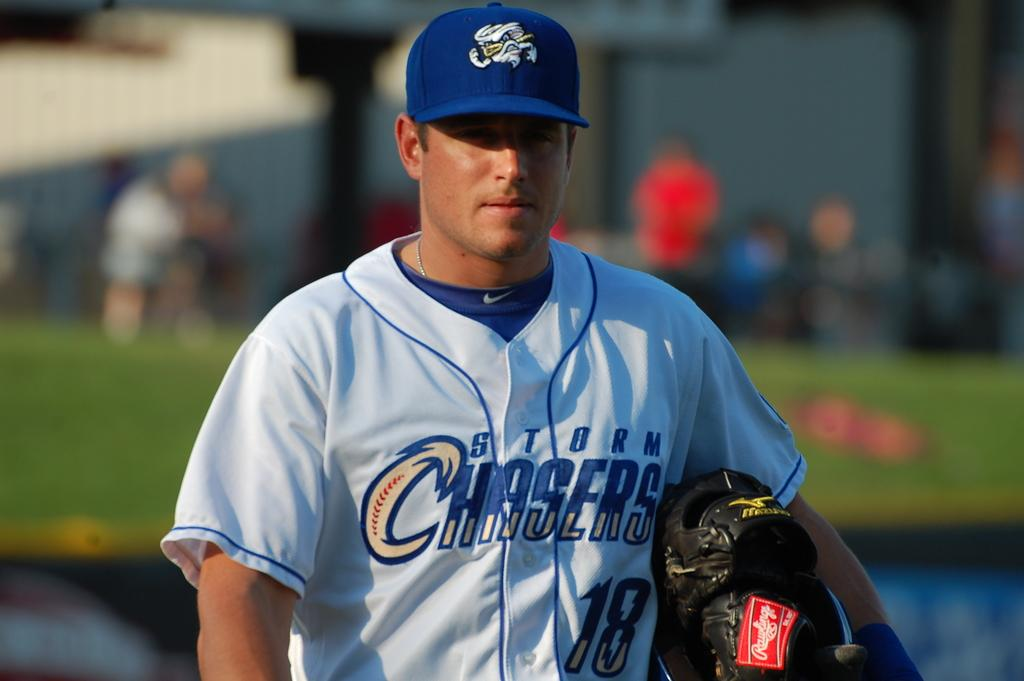<image>
Relay a brief, clear account of the picture shown. A man in a baseball uniform that says Storm Chasers on it. 